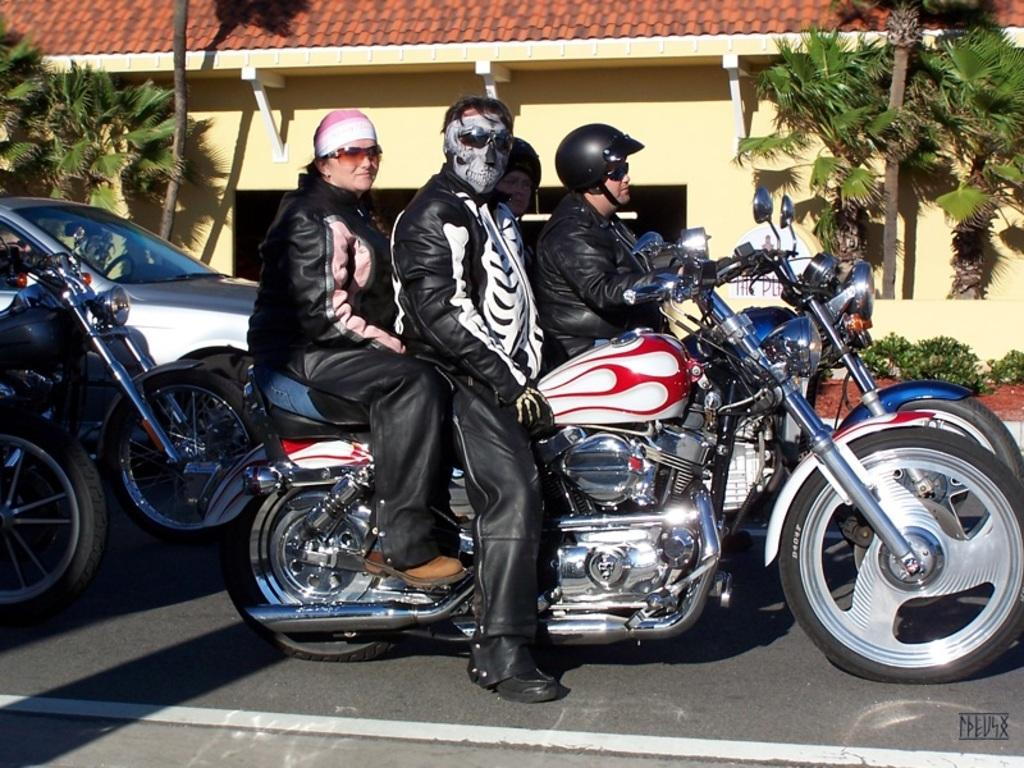What are the persons in the image doing? The persons are sitting on a bike. How are the persons interacting with the bike? The persons are holding the bike. What can be seen in the background of the image? There is a house and trees in the background of the image. What else is visible in the image? Vehicles are visible on the road in the image. What type of icicle can be seen hanging from the house in the image? There is no icicle present in the image; it is not cold enough for icicles to form. What news is being discussed by the persons sitting on the bike? There is no indication in the image that the persons are discussing any news. 